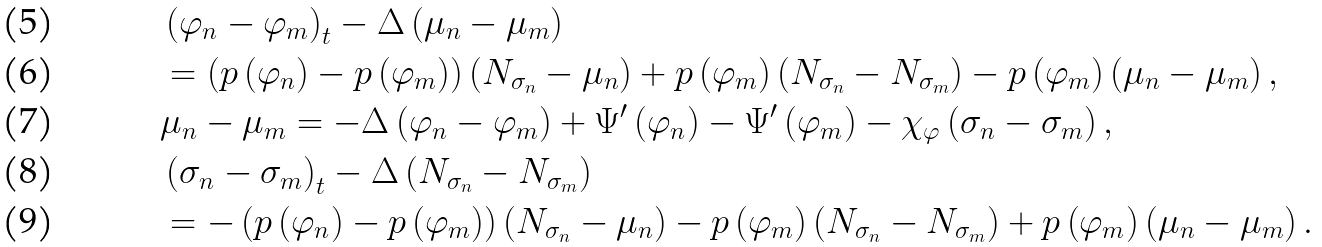Convert formula to latex. <formula><loc_0><loc_0><loc_500><loc_500>& \left ( \varphi _ { n } - \varphi _ { m } \right ) _ { t } - \Delta \left ( \mu _ { n } - \mu _ { m } \right ) \\ & = \left ( p \left ( \varphi _ { n } \right ) - p \left ( \varphi _ { m } \right ) \right ) \left ( N _ { \sigma _ { n } } - \mu _ { n } \right ) + p \left ( \varphi _ { m } \right ) \left ( N _ { \sigma _ { n } } - N _ { \sigma _ { m } } \right ) - p \left ( \varphi _ { m } \right ) \left ( \mu _ { n } - \mu _ { m } \right ) , \\ & \mu _ { n } - \mu _ { m } = - \Delta \left ( \varphi _ { n } - \varphi _ { m } \right ) + \Psi ^ { \prime } \left ( \varphi _ { n } \right ) - \Psi ^ { \prime } \left ( \varphi _ { m } \right ) - \chi _ { \varphi } \left ( \sigma _ { n } - \sigma _ { m } \right ) , \\ & \left ( \sigma _ { n } - \sigma _ { m } \right ) _ { t } - \Delta \left ( N _ { \sigma _ { n } } - N _ { \sigma _ { m } } \right ) \\ & = - \left ( p \left ( \varphi _ { n } \right ) - p \left ( \varphi _ { m } \right ) \right ) \left ( N _ { \sigma _ { n } } - \mu _ { n } \right ) - p \left ( \varphi _ { m } \right ) \left ( N _ { \sigma _ { n } } - N _ { \sigma _ { m } } \right ) + p \left ( \varphi _ { m } \right ) \left ( \mu _ { n } - \mu _ { m } \right ) .</formula> 